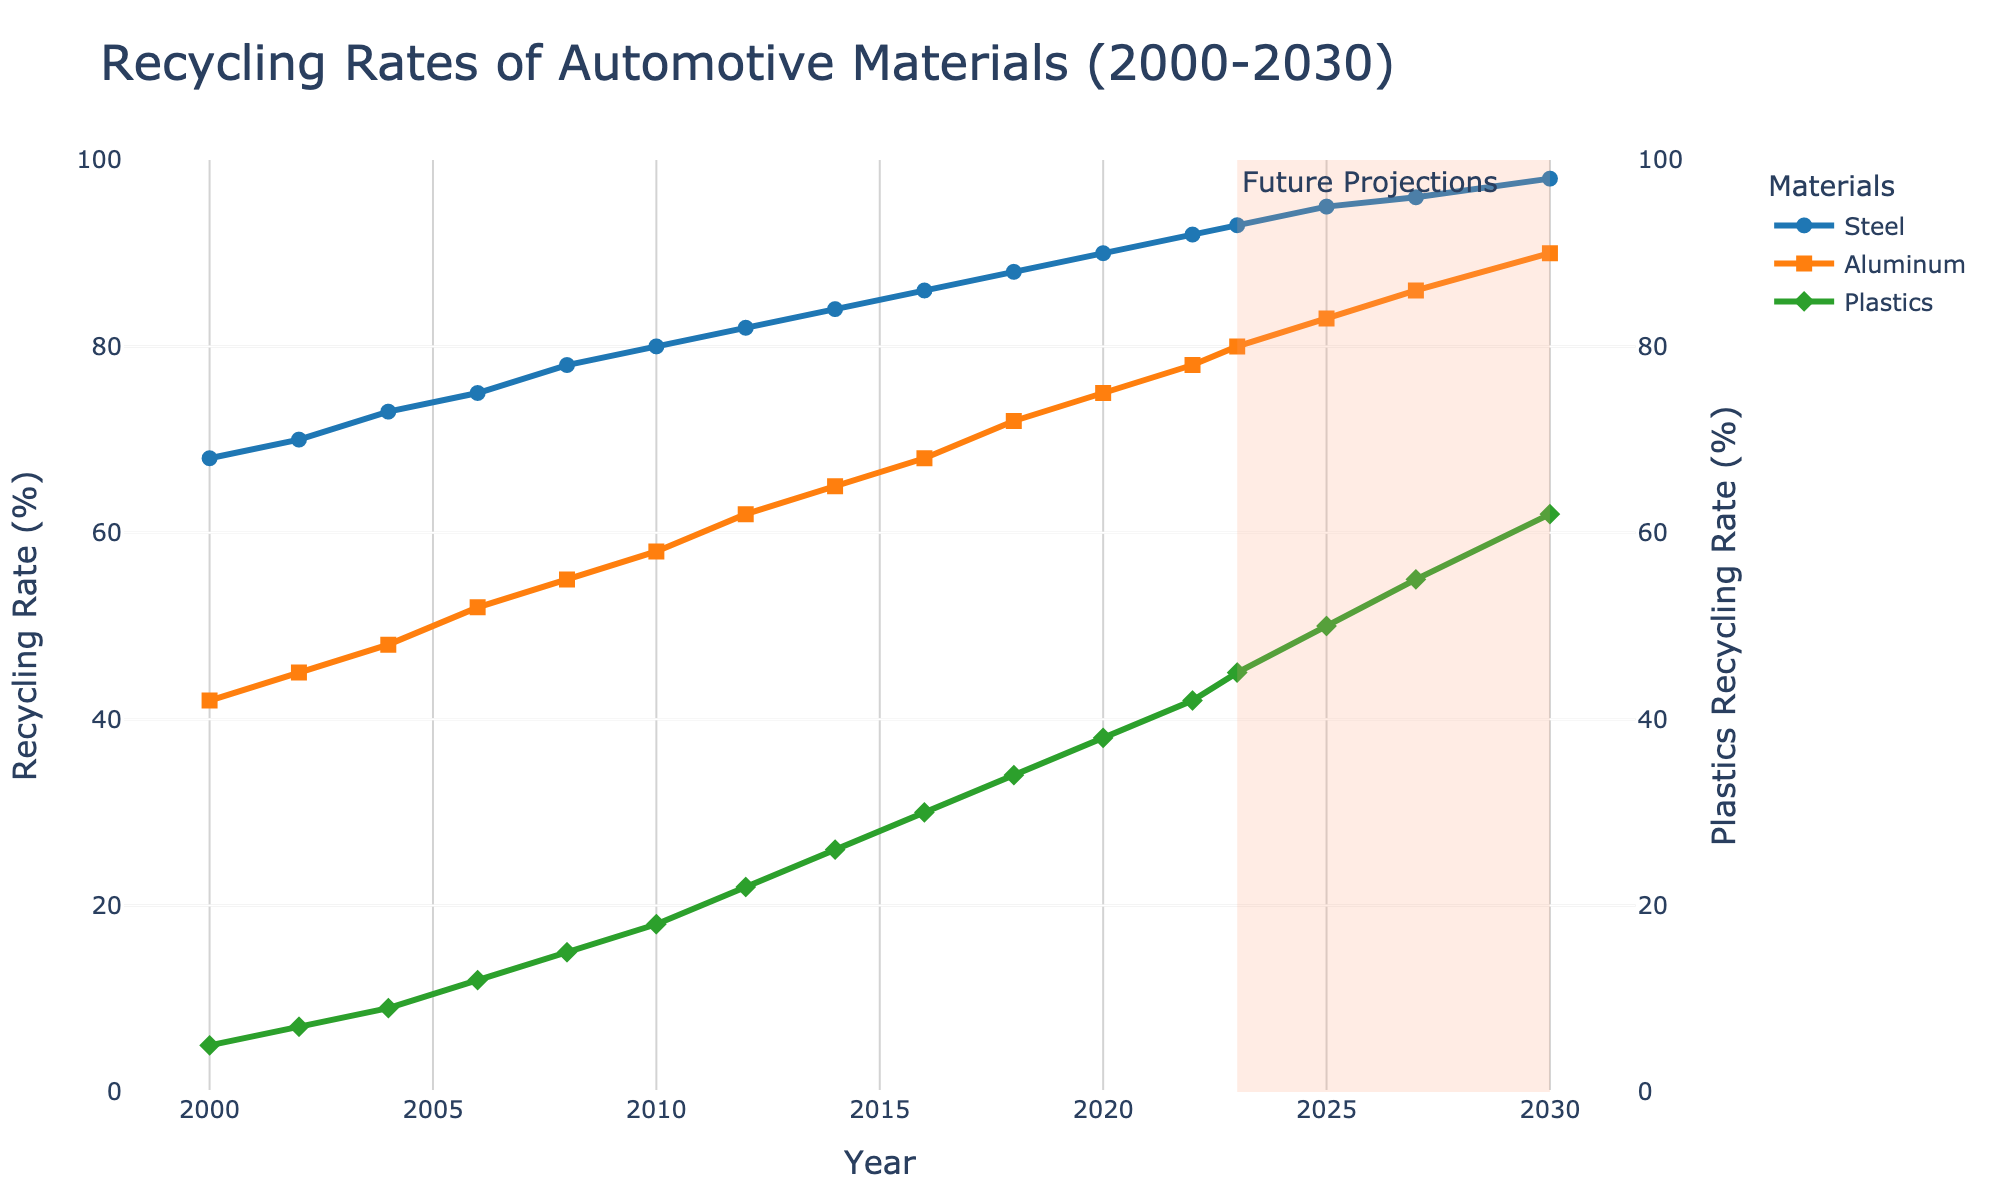what is the recycling rate of steel in 2008? Locate the data point for steel in the year 2008 on the chart; the corresponding recycling rate is indicated next to it.
Answer: 78% which material had the highest recycling rate in the year 2020? Compare the recycling rates for steel, aluminum, and plastics in 2020. Steel shows the highest recycling rate among them.
Answer: Steel by how many percentage points did the recycling rate of aluminum increase from 2000 to 2023? Subtract the recycling rate of aluminum in 2000 (42%) from its rate in 2023 (80%).
Answer: 38% how does the recycling rate of plastics in 2023 compare to the rate projected for 2030? Compare the recycling rate of plastics in the year 2023 (45%) with the projected rate in 2030 (62%).
Answer: Plastics recycling rate is projected to increase by 17 percentage points from 2023 to 2030 what are the projected recycling rates of aluminum and plastics in 2027? Identify the projected data points for aluminum and plastics in the year 2027 on the chart.
Answer: 86% for aluminum, 55% for plastics what is the trend observed for the recycling rate of steel from 2000 to 2030? Observe the line representing steel; it consistently trends upward from 68% in 2000 to a projected 98% in 2030.
Answer: Upward trend which year marks the beginning of future projections in the chart? Locate the shaded area denoting future projections and note the starting year.
Answer: 2023 calculate the average recycling rate of plastics from 2000 to 2010 Sum the recycling rates of plastics from 2000 (5%), 2002 (7%), 2004 (9%), 2006 (12%), 2008 (15%), and 2010 (18%) and divide by the number of years (6). (5+7+9+12+15+18)/6 = 66/6 = 11%
Answer: 11% compare the overall recycling rates of steel and aluminum in 2014. Which one had a larger increase since 2000? Calculate the difference in recycling rates for steel and aluminum between 2000 and 2014. Steel: 84% - 68% = 16%; Aluminum: 65% - 42% = 23%. Aluminum had a larger increase.
Answer: Aluminum what visual indication is used to denote future projections on the chart? The chart uses a shaded area in light salmon color starting from the year 2023 to indicate future projections.
Answer: Shaded area 